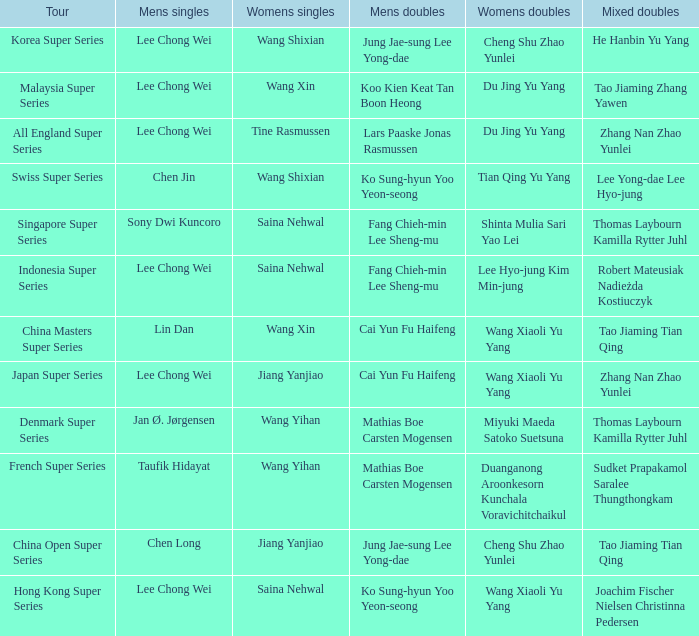Who were the womens doubles when the mixed doubles were zhang nan zhao yunlei on the tour all england super series? Du Jing Yu Yang. 